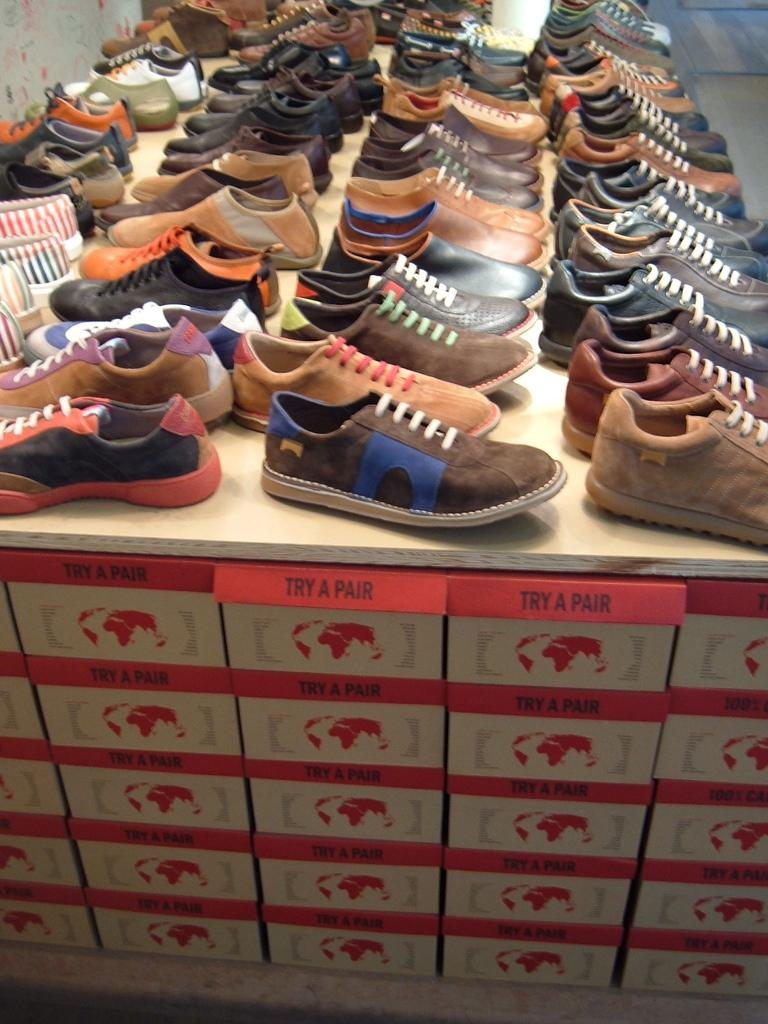What types of items are present in the image? There are different types of shoes in the image. Where are the shoes placed? The shoes are kept on a cotton box. What can be seen in the background of the image? There is a wall visible in the top left corner of the image. What type of star can be seen in the image? There is no star present in the image; it features different types of shoes on a cotton box with a wall visible in the background. 